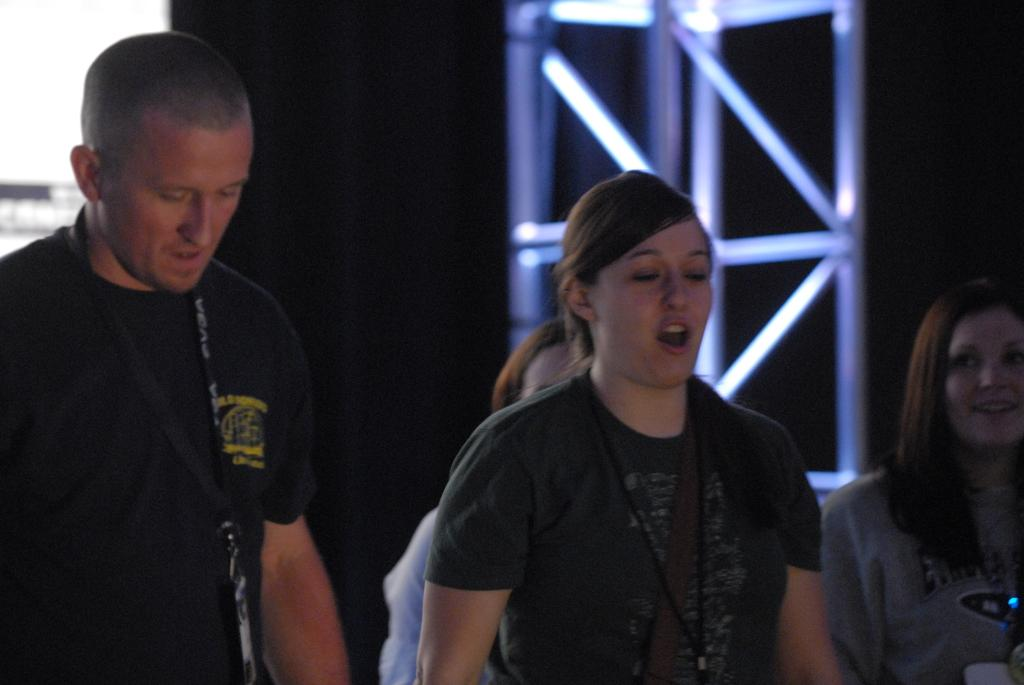How many people are in the foreground of the image? There are four persons in the foreground of the image. What can be seen in the background of the image? There are metal rods and a wall in the background of the image. What is the color of the background in the image? The background has a dark color. Where might this image have been taken? The image may have been taken in a hall, based on the presence of metal rods and a wall in the background. What type of hydrant is visible in the image? There is no hydrant present in the image. Can you tell me how many brothers are in the image? The image does not provide information about any brothers, as it only shows four persons in the foreground. 